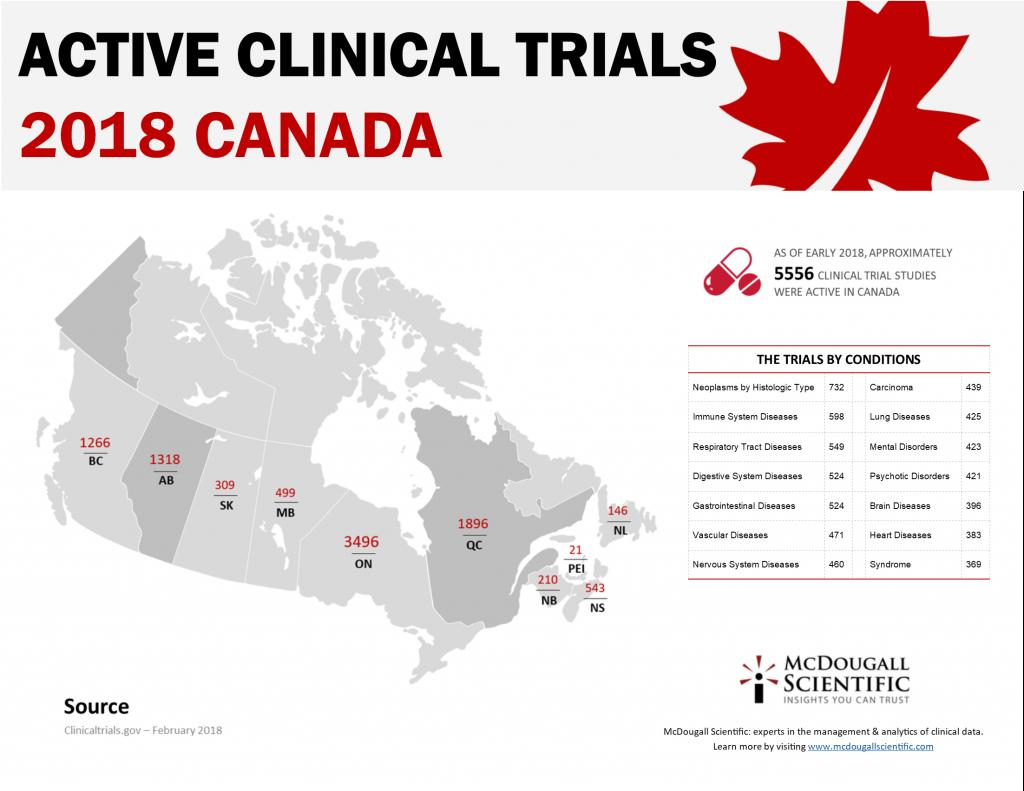Highlight a few significant elements in this photo. There have been a total of 779 clinical trial studies conducted on brain diseases and heart diseases combined. More clinical trials have been conducted for immune system diseases than for respiratory tract diseases. For two diseases, the number of trials conducted is equal. These diseases are gastrointestinal diseases and digestive system diseases. There have been 844 clinical trial studies on mental disorders and psychotic disorders combined. There have been 1073 clinical trial studies conducted on respiratory tract diseases and digestive system diseases combined. 